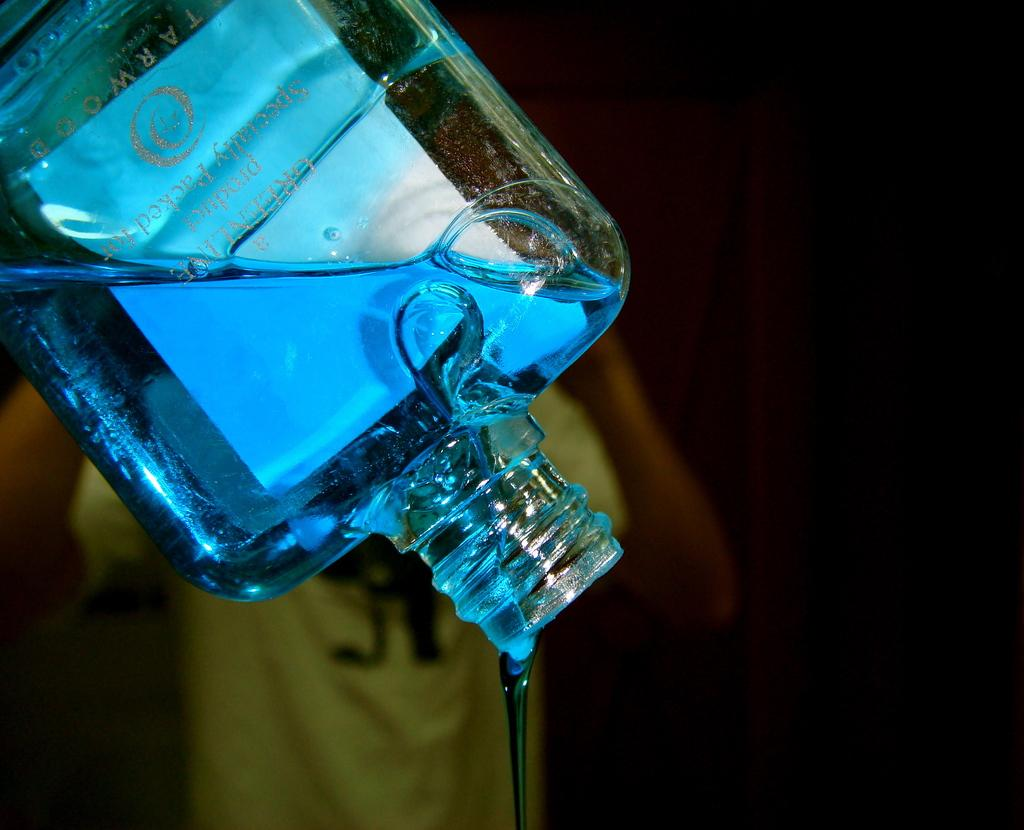What object is present in the image that is made of glass? There is a glass bottle in the image. What is inside the glass bottle? The glass bottle contains a blue color liquid. Can you describe the person in the background of the image? The person in the background is wearing a yellow t-shirt. Can you see a kitten playing near the lake in the image? There is no kitten or lake present in the image. Is there a crack in the glass bottle in the image? The image does not show any cracks in the glass bottle. 